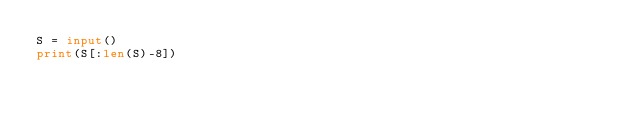Convert code to text. <code><loc_0><loc_0><loc_500><loc_500><_Python_>S = input()
print(S[:len(S)-8])</code> 